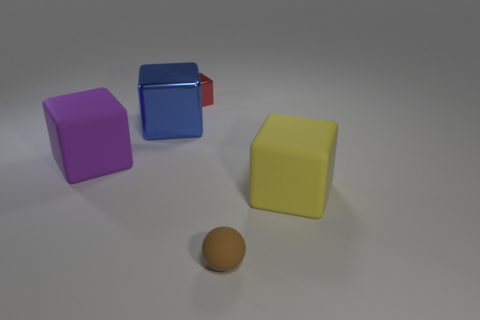Subtract all gray cubes. Subtract all gray cylinders. How many cubes are left? 4 Add 3 big purple objects. How many objects exist? 8 Subtract all cubes. How many objects are left? 1 Add 3 small brown things. How many small brown things are left? 4 Add 5 large shiny balls. How many large shiny balls exist? 5 Subtract 0 brown cylinders. How many objects are left? 5 Subtract all tiny rubber cylinders. Subtract all red shiny blocks. How many objects are left? 4 